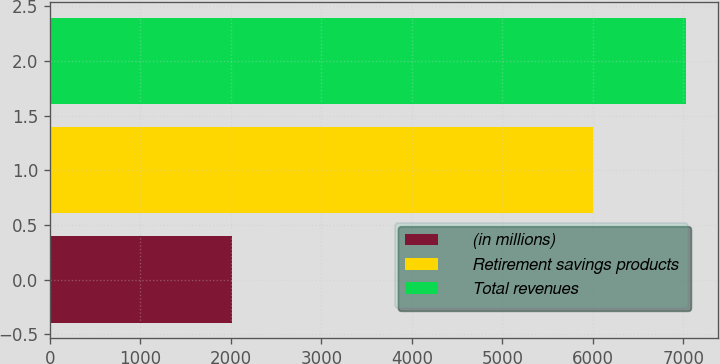Convert chart. <chart><loc_0><loc_0><loc_500><loc_500><bar_chart><fcel>(in millions)<fcel>Retirement savings products<fcel>Total revenues<nl><fcel>2011<fcel>6006<fcel>7033<nl></chart> 